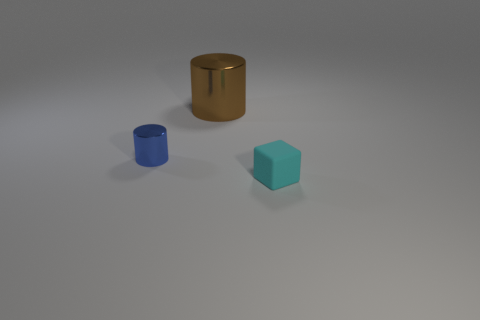Do the blue metal object and the shiny thing behind the tiny cylinder have the same shape?
Your answer should be compact. Yes. What number of blue objects are the same shape as the big brown object?
Your answer should be compact. 1. What material is the blue thing that is the same size as the cyan matte thing?
Your response must be concise. Metal. There is a metallic thing that is behind the cylinder that is on the left side of the metallic cylinder right of the blue metal thing; how big is it?
Give a very brief answer. Large. What is the size of the thing that is made of the same material as the large cylinder?
Provide a succinct answer. Small. Does the blue shiny object have the same size as the cyan matte object in front of the large cylinder?
Keep it short and to the point. Yes. What shape is the small thing that is to the right of the tiny blue thing?
Offer a terse response. Cube. Are there any cyan matte cubes left of the tiny thing behind the small thing on the right side of the tiny metal thing?
Keep it short and to the point. No. Is there any other thing that is made of the same material as the small cube?
Provide a succinct answer. No. How many blocks are large things or cyan objects?
Your answer should be compact. 1. 